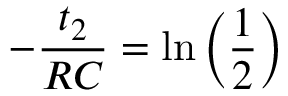<formula> <loc_0><loc_0><loc_500><loc_500>- \frac { t _ { 2 } } { R C } = \ln { \left ( \frac { 1 } { 2 } \right ) }</formula> 